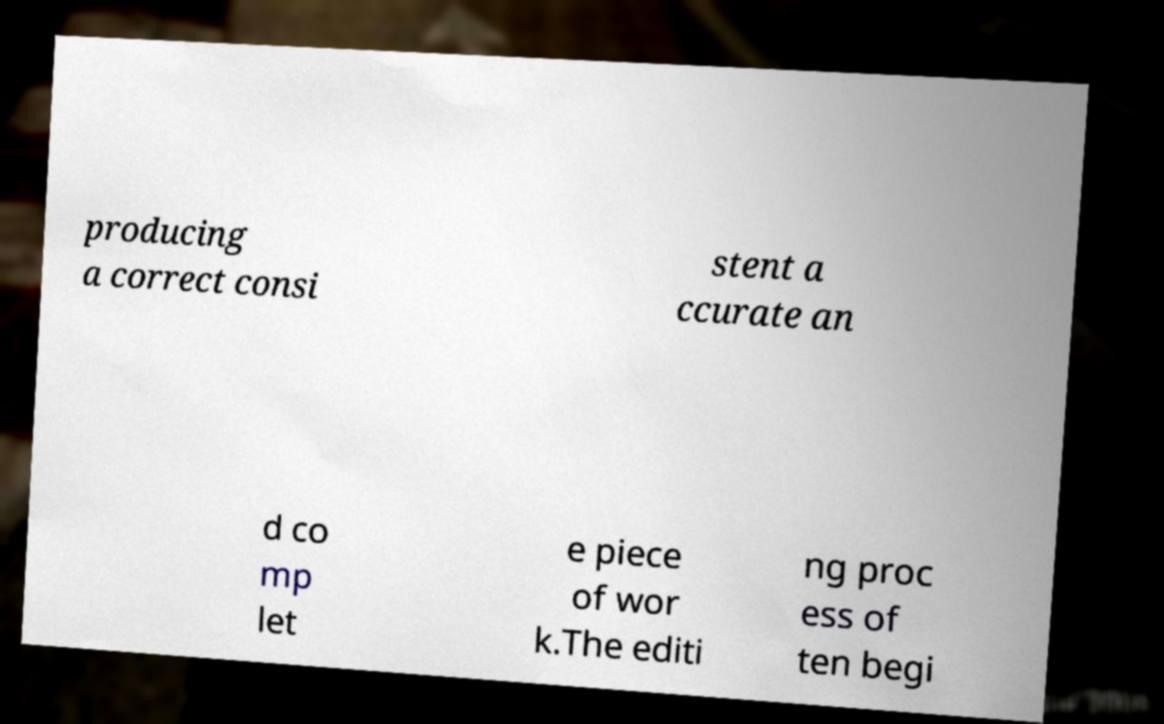I need the written content from this picture converted into text. Can you do that? producing a correct consi stent a ccurate an d co mp let e piece of wor k.The editi ng proc ess of ten begi 